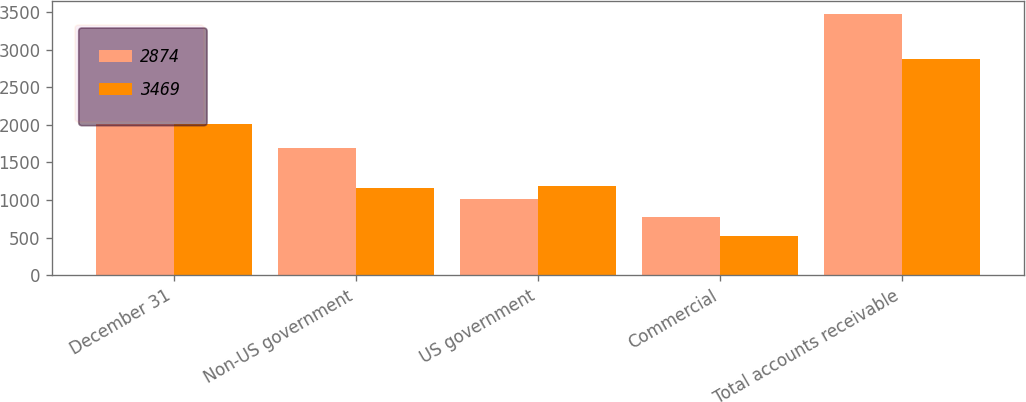Convert chart. <chart><loc_0><loc_0><loc_500><loc_500><stacked_bar_chart><ecel><fcel>December 31<fcel>Non-US government<fcel>US government<fcel>Commercial<fcel>Total accounts receivable<nl><fcel>2874<fcel>2008<fcel>1689<fcel>1009<fcel>771<fcel>3469<nl><fcel>3469<fcel>2007<fcel>1163<fcel>1187<fcel>524<fcel>2874<nl></chart> 